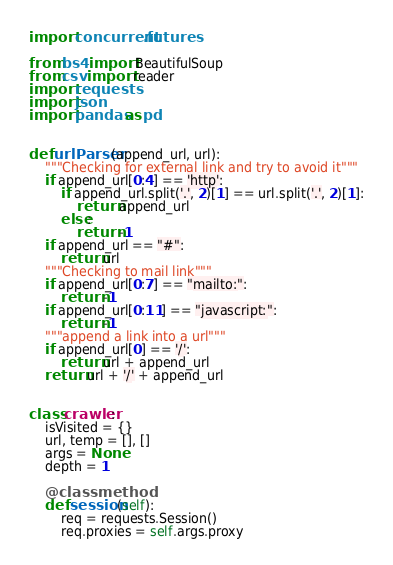<code> <loc_0><loc_0><loc_500><loc_500><_Python_>import concurrent.futures

from bs4 import BeautifulSoup
from csv import reader
import requests
import json
import pandas as pd


def urlParser(append_url, url):
    """Checking for external link and try to avoid it"""
    if append_url[0:4] == 'http':
        if append_url.split('.', 2)[1] == url.split('.', 2)[1]:
            return append_url
        else:
            return -1
    if append_url == "#":
        return url
    """Checking to mail link"""
    if append_url[0:7] == "mailto:":
        return -1
    if append_url[0:11] == "javascript:":
        return -1
    """append a link into a url"""
    if append_url[0] == '/':
        return url + append_url
    return url + '/' + append_url


class crawler:
    isVisited = {}
    url, temp = [], []
    args = None
    depth = 1

    @classmethod
    def session(self):
        req = requests.Session()
        req.proxies = self.args.proxy</code> 